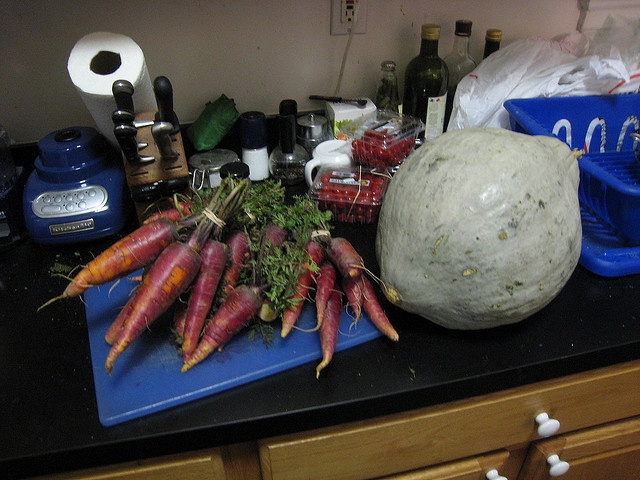Describe the objects in this image and their specific colors. I can see carrot in black, maroon, and brown tones, carrot in black, maroon, and brown tones, bottle in black, darkgray, olive, and gray tones, carrot in black, maroon, and brown tones, and carrot in black, maroon, and brown tones in this image. 